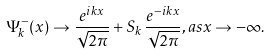Convert formula to latex. <formula><loc_0><loc_0><loc_500><loc_500>\Psi _ { k } ^ { - } ( x ) \rightarrow \frac { e ^ { i k x } } { \sqrt { 2 \pi } } + S _ { k } \, \frac { e ^ { - i k x } } { \sqrt { 2 \pi } } , a s x \rightarrow - \infty .</formula> 